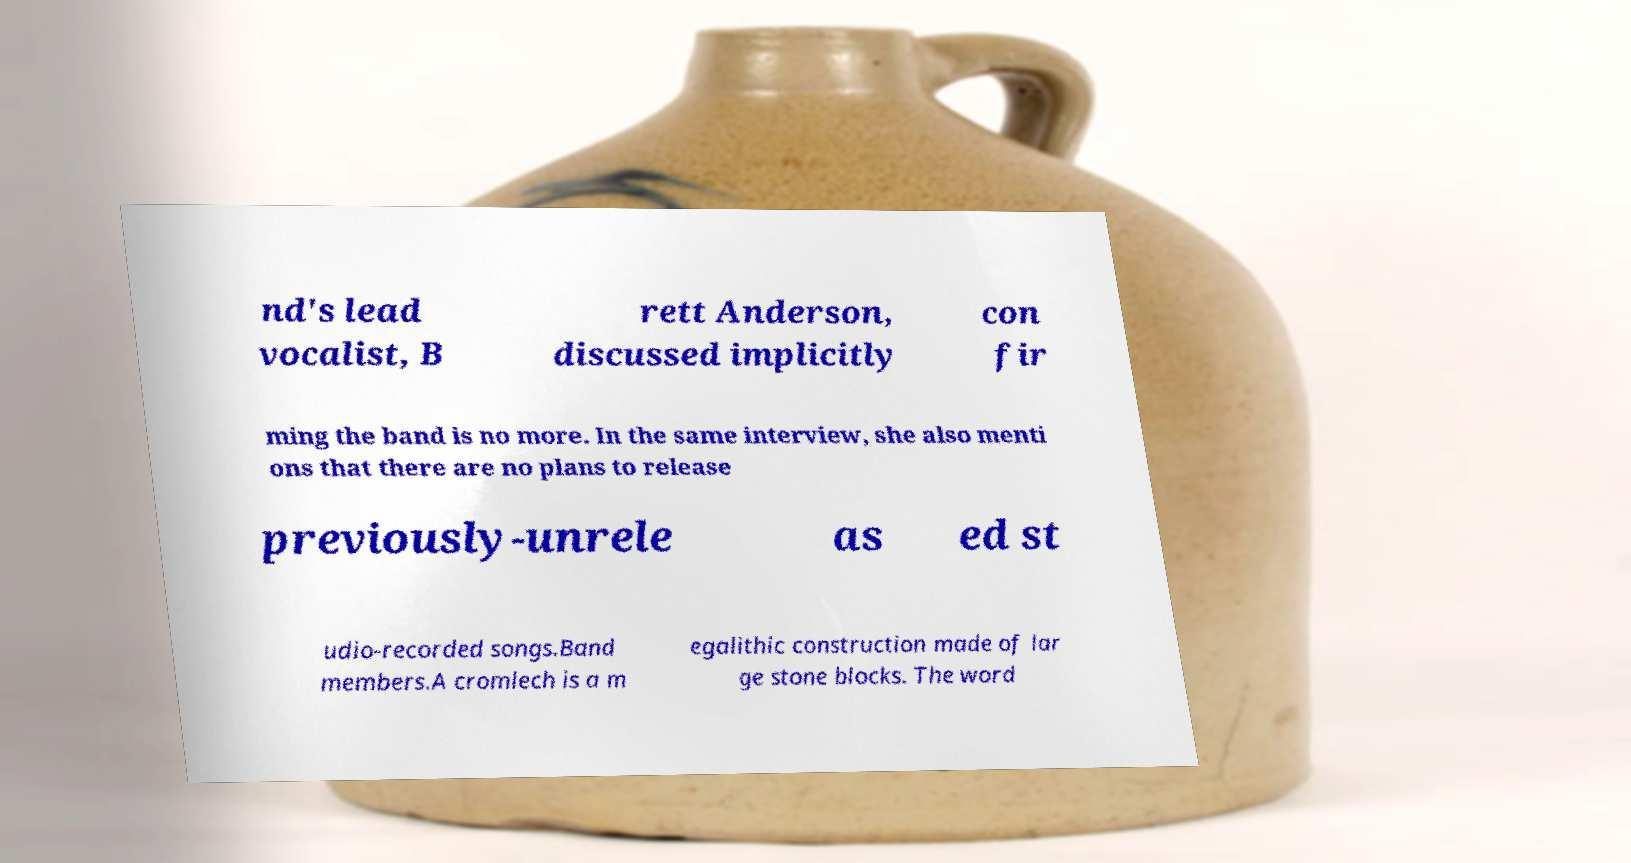For documentation purposes, I need the text within this image transcribed. Could you provide that? nd's lead vocalist, B rett Anderson, discussed implicitly con fir ming the band is no more. In the same interview, she also menti ons that there are no plans to release previously-unrele as ed st udio-recorded songs.Band members.A cromlech is a m egalithic construction made of lar ge stone blocks. The word 